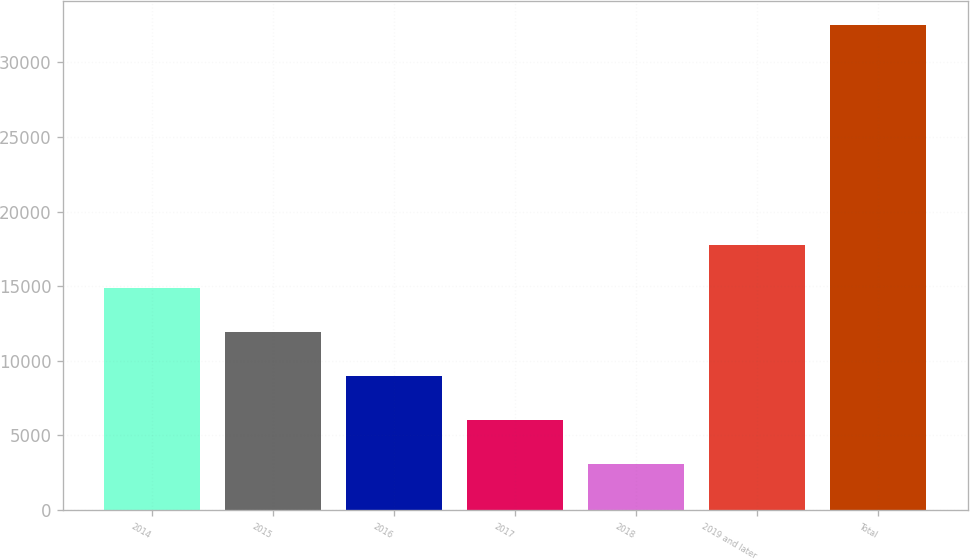Convert chart. <chart><loc_0><loc_0><loc_500><loc_500><bar_chart><fcel>2014<fcel>2015<fcel>2016<fcel>2017<fcel>2018<fcel>2019 and later<fcel>Total<nl><fcel>14849.6<fcel>11904.7<fcel>8959.8<fcel>6014.9<fcel>3070<fcel>17794.5<fcel>32519<nl></chart> 